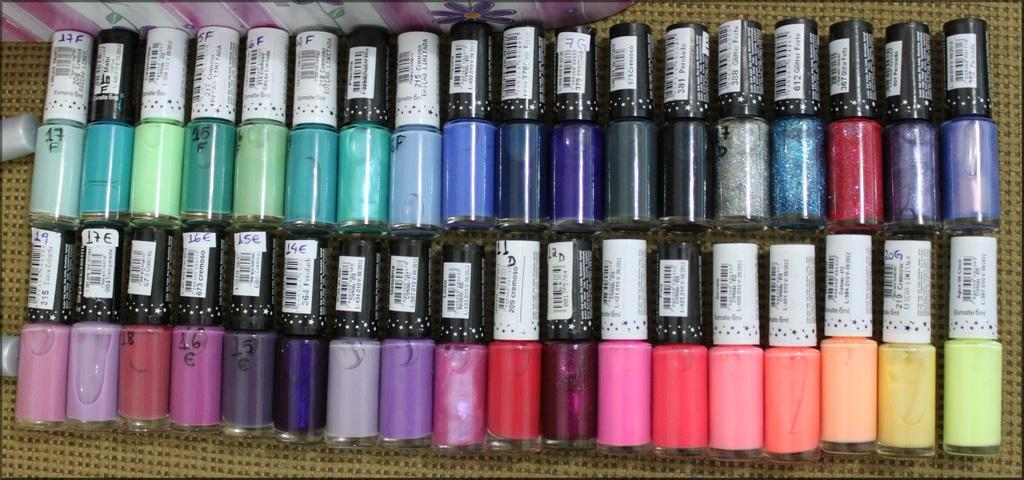What objects are present in the image? There are bottles in the image. How many cherries are on the basketball in the image? There are no cherries or basketballs present in the image; only bottles are visible. 